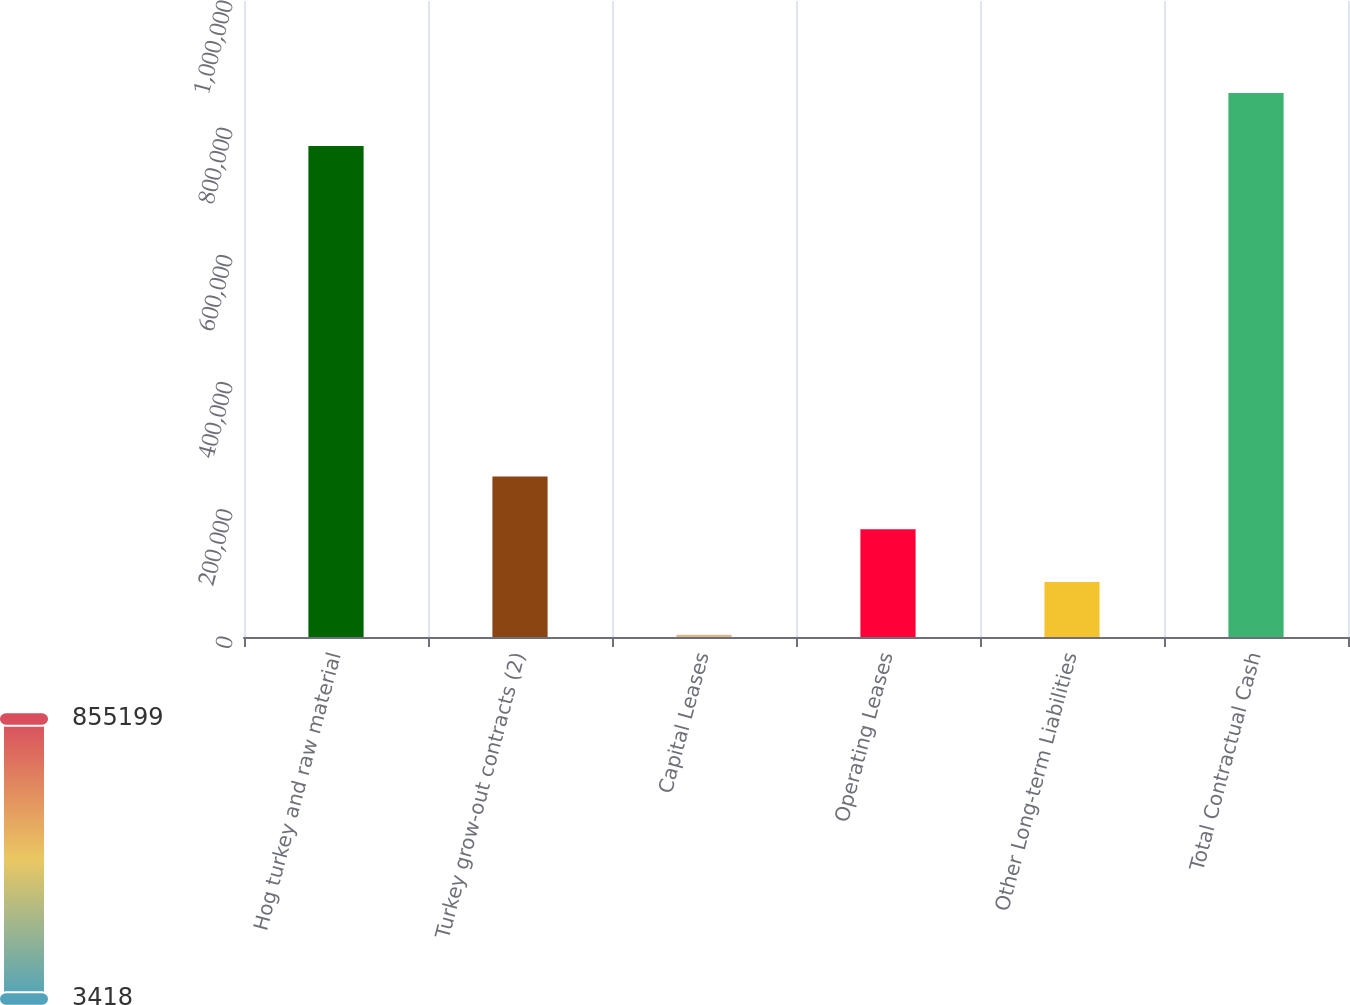Convert chart to OTSL. <chart><loc_0><loc_0><loc_500><loc_500><bar_chart><fcel>Hog turkey and raw material<fcel>Turkey grow-out contracts (2)<fcel>Capital Leases<fcel>Operating Leases<fcel>Other Long-term Liabilities<fcel>Total Contractual Cash<nl><fcel>772202<fcel>252410<fcel>3418<fcel>169413<fcel>86415.4<fcel>855199<nl></chart> 